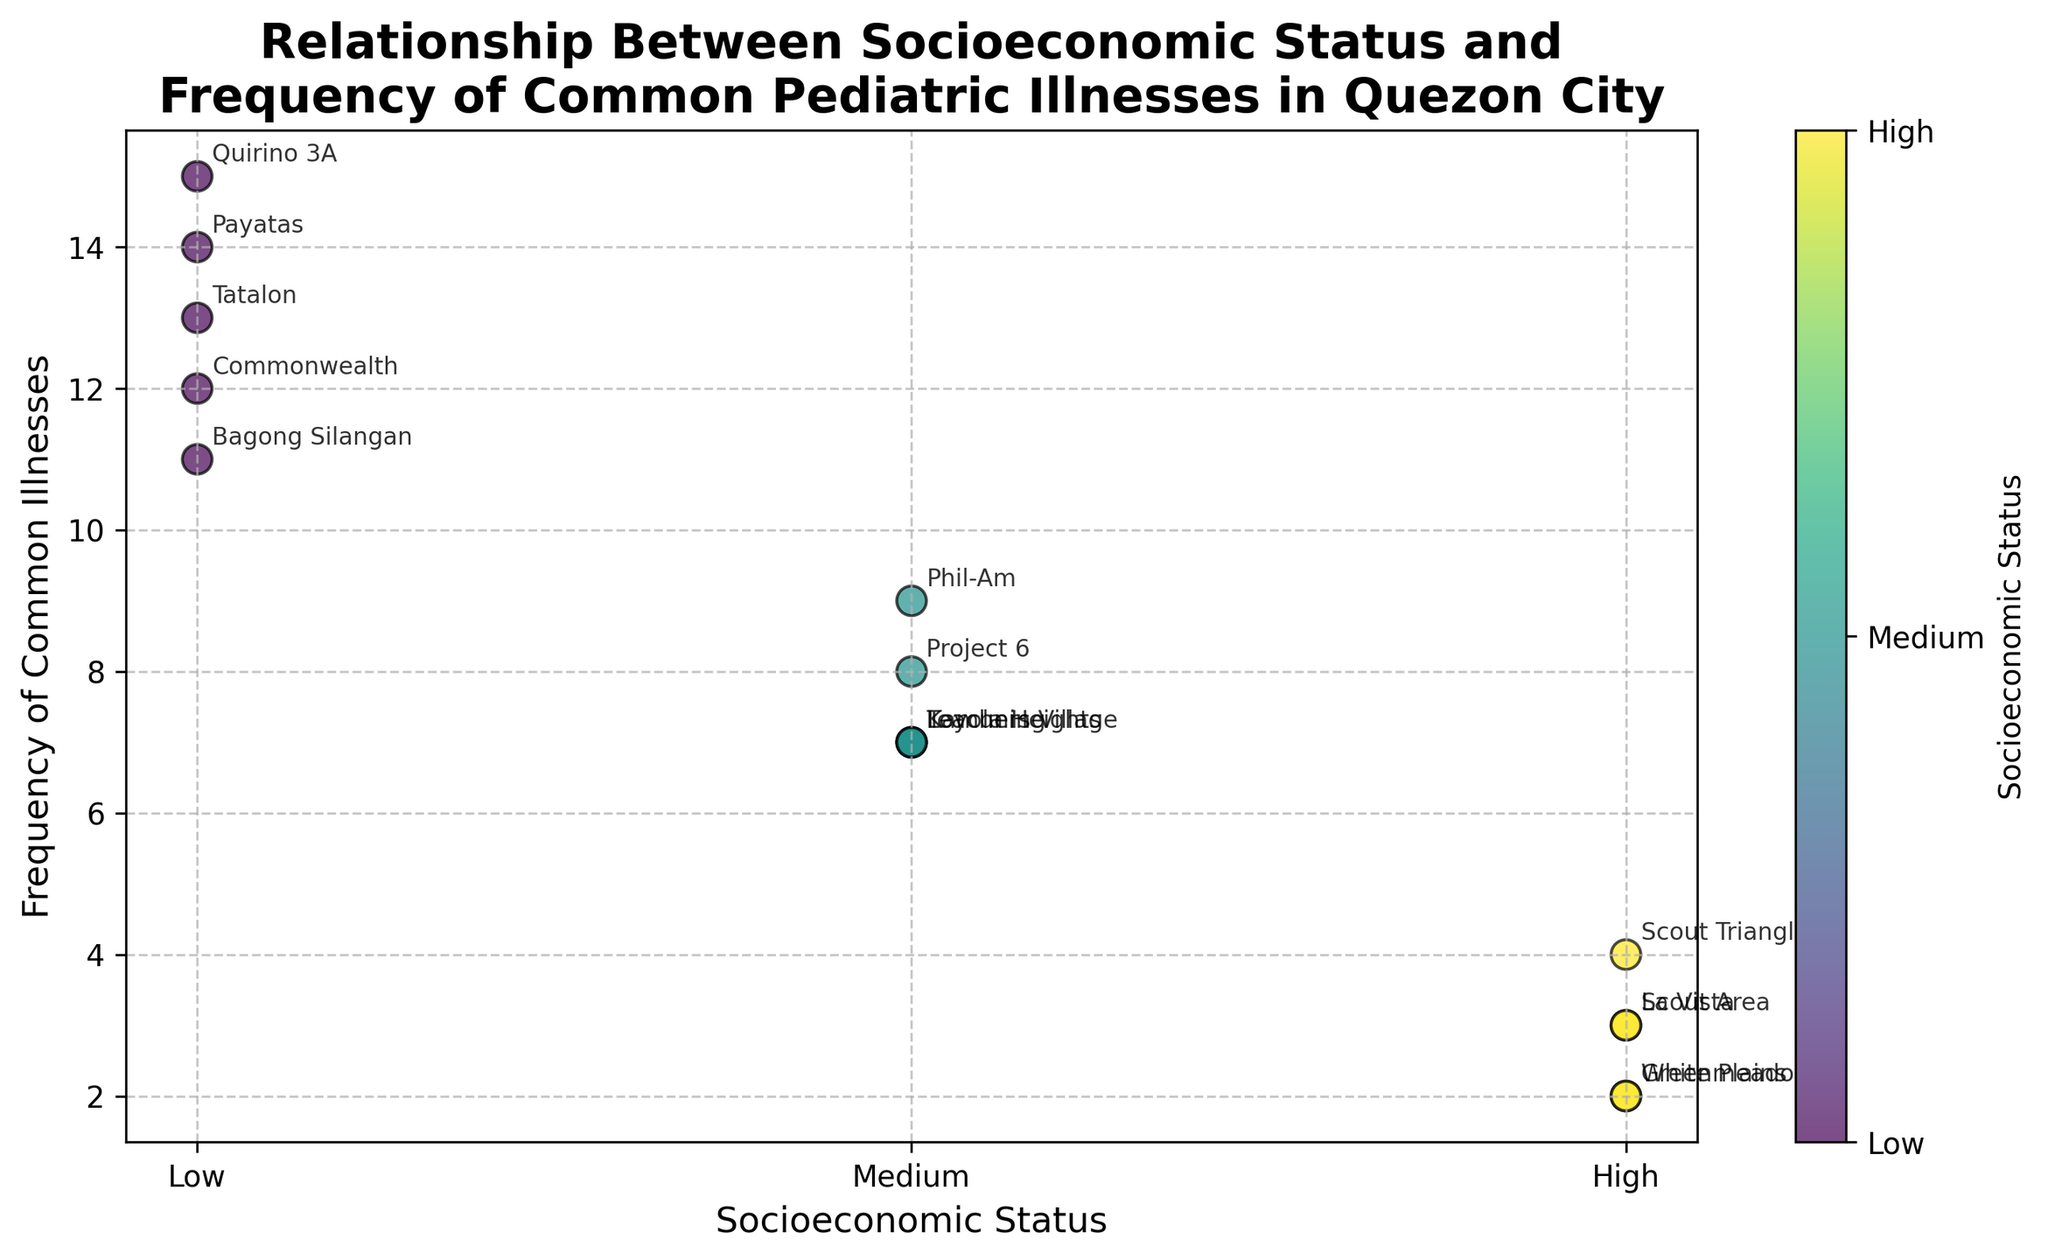Which neighborhood has the highest frequency of common pediatric illnesses? By looking at the scatter plot, we identify the point that is highest on the y-axis. The point corresponding to the neighborhood "Quirino 3A" appears at the highest position on the y-axis with a value of 15.
Answer: Quirino 3A What is the socioeconomic status associated with the highest frequency of illnesses? The highest frequency of common pediatric illnesses is 15, indicated by the neighborhood "Quirino 3A". The neighborhood "Quirino 3A" has a "Low" socioeconomic status.
Answer: Low How many neighborhoods have a medium socioeconomic status and what are their frequencies of illnesses? There are five neighborhoods with a medium socioeconomic status: Kamuning, Project 6, Phil-Am, Loyola Heights, and Teachers Village. Their frequencies of illnesses are 7, 8, 9, 7, and 7 respectively.
Answer: 5 neighborhoods (7, 8, 9, 7, 7) Which socioeconomic status group has the least variation in the frequency of common illnesses? To determine variation, compare the range (difference between max and min values) for each socioeconomic status group: Low (15-11=4), Medium (9-7=2), High (4-2=2). The "Medium" and "High" groups both have the least variation of 2.
Answer: Medium and High Is there a trend between socioeconomic status and the frequency of common pediatric illnesses? By examining the scatter plot, we observe that neighborhoods with lower socioeconomic status (Low) generally have higher frequencies of common illnesses. In contrast, neighborhoods with higher socioeconomic statuses (High) tend to have lower frequencies of common illnesses.
Answer: Yes, lower SES, higher illnesses How many neighborhoods belong to the high socioeconomic status category and what are their illnesses frequencies? There are four neighborhoods in the high socioeconomic status category: Scout Area, White Plains, Scout Triangle, and La Vista. Their frequencies of common illnesses are 3, 2, 4, and 3 respectively.
Answer: 4 neighborhoods (3, 2, 4, 3) What is the average frequency of common pediatric illnesses for neighborhoods with a low socioeconomic status? Sum the frequencies of common illnesses for low socioeconomic neighborhoods (14 + 13 + 15 + 12 + 11 = 65). Divide by the number of neighborhoods (65 / 5).
Answer: 13 Which neighborhoods have a frequency of common illnesses below 5, and what is their socioeconomic status? By looking at the scatter plot, points below the y-axis value of 5 are Scout Area, White Plains, La Vista, and Greenmeadows. Their socioeconomic statuses are all "High".
Answer: Scout Area, White Plains, La Vista, Greenmeadows - High 